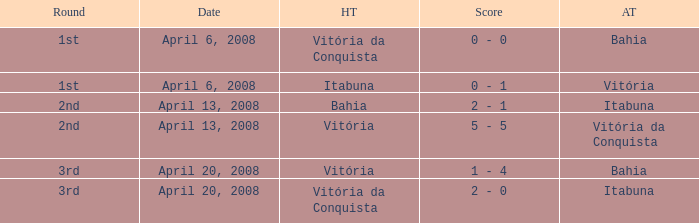What home team has a score of 5 - 5? Vitória. 